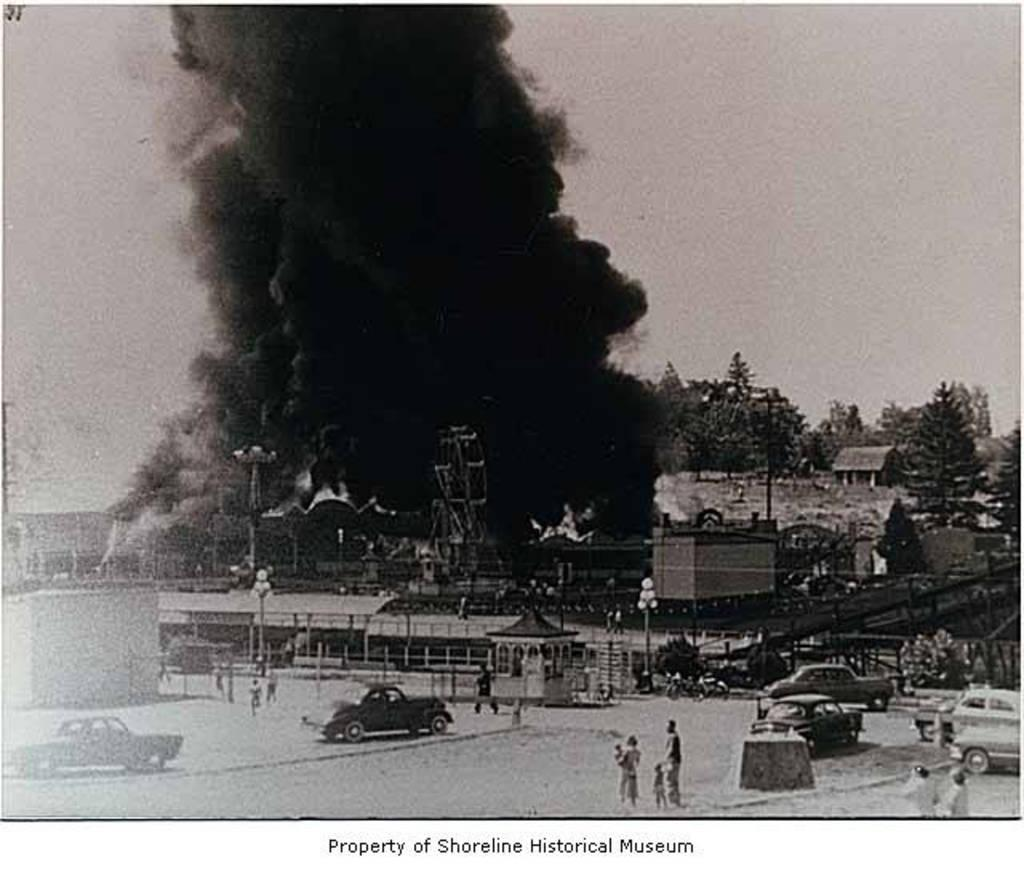What is the color scheme of the image? The image is black and white. What type of vehicles can be seen in the image? There are cars in the image. Are there any people visible in the image? Yes, there are persons in the image. What other objects can be seen in the image? There are poles, lights, buildings, and trees in the image. What is the atmospheric condition in the image? There is smoke in the image, which may indicate a smoky or foggy atmosphere. What is visible in the background of the image? The sky is visible in the background of the image. What type of furniture can be seen in the image? There is no furniture present in the image. How many persons have experienced loss in the image? There is no indication of loss or any emotional state of the persons in the image. 